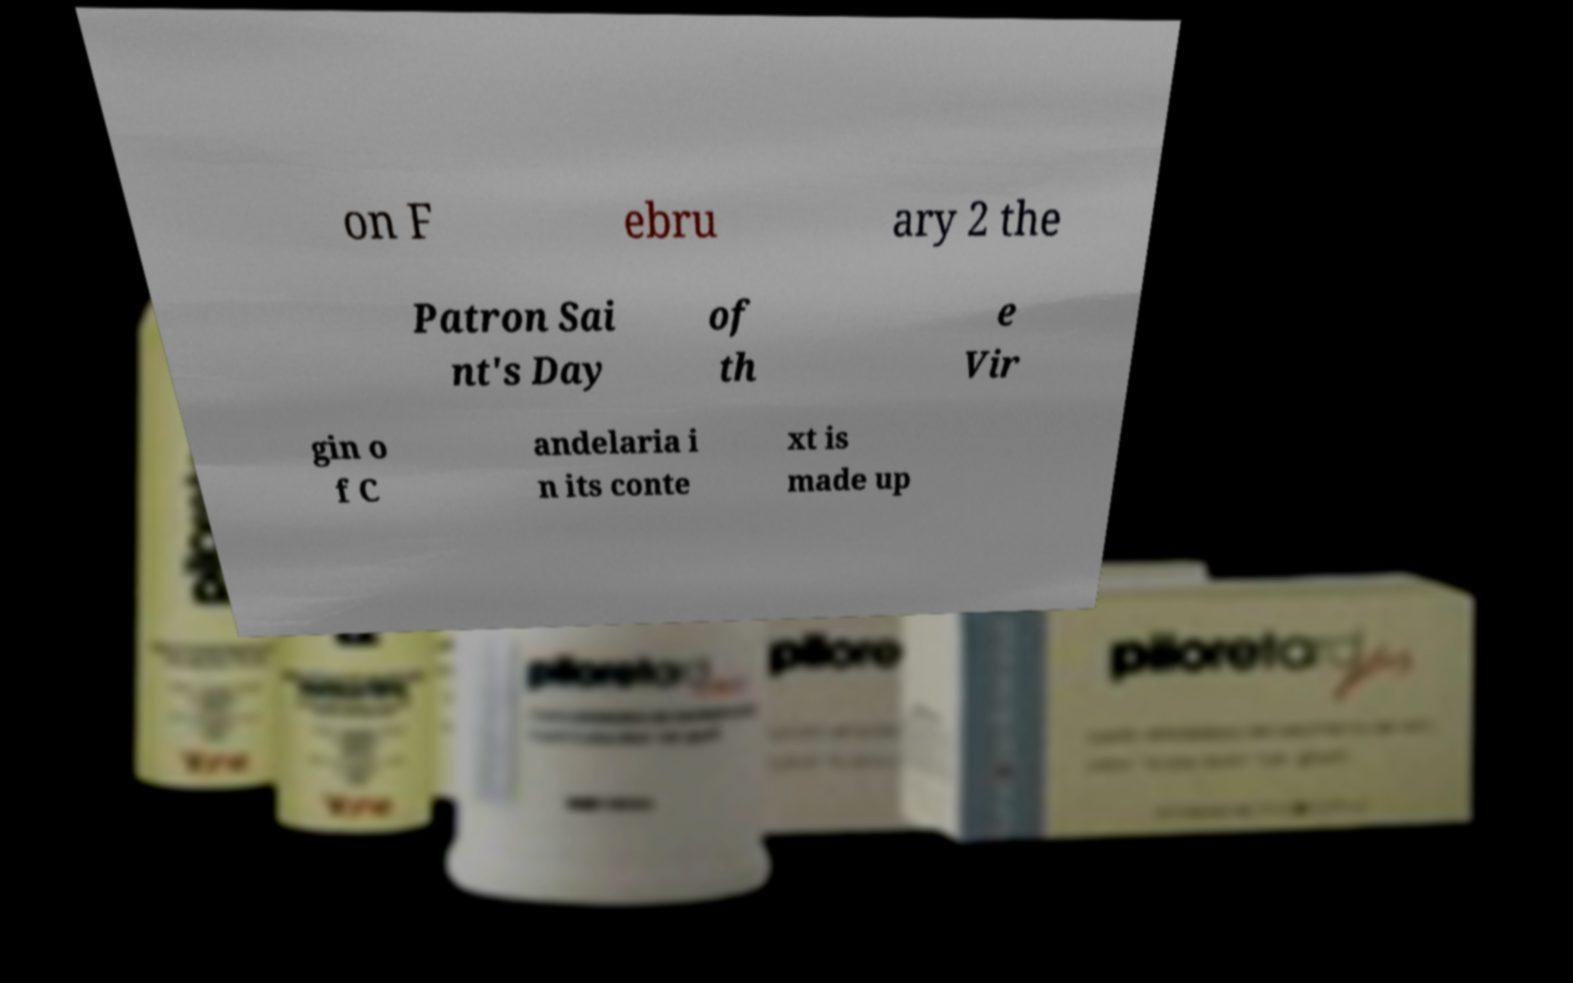Could you assist in decoding the text presented in this image and type it out clearly? on F ebru ary 2 the Patron Sai nt's Day of th e Vir gin o f C andelaria i n its conte xt is made up 